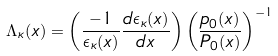Convert formula to latex. <formula><loc_0><loc_0><loc_500><loc_500>\Lambda _ { \kappa } ( x ) = \left ( \frac { - 1 } { \epsilon _ { \kappa } ( x ) } \frac { d \epsilon _ { \kappa } ( x ) } { d x } \right ) \left ( \frac { p _ { 0 } ( x ) } { P _ { 0 } ( x ) } \right ) ^ { - 1 }</formula> 